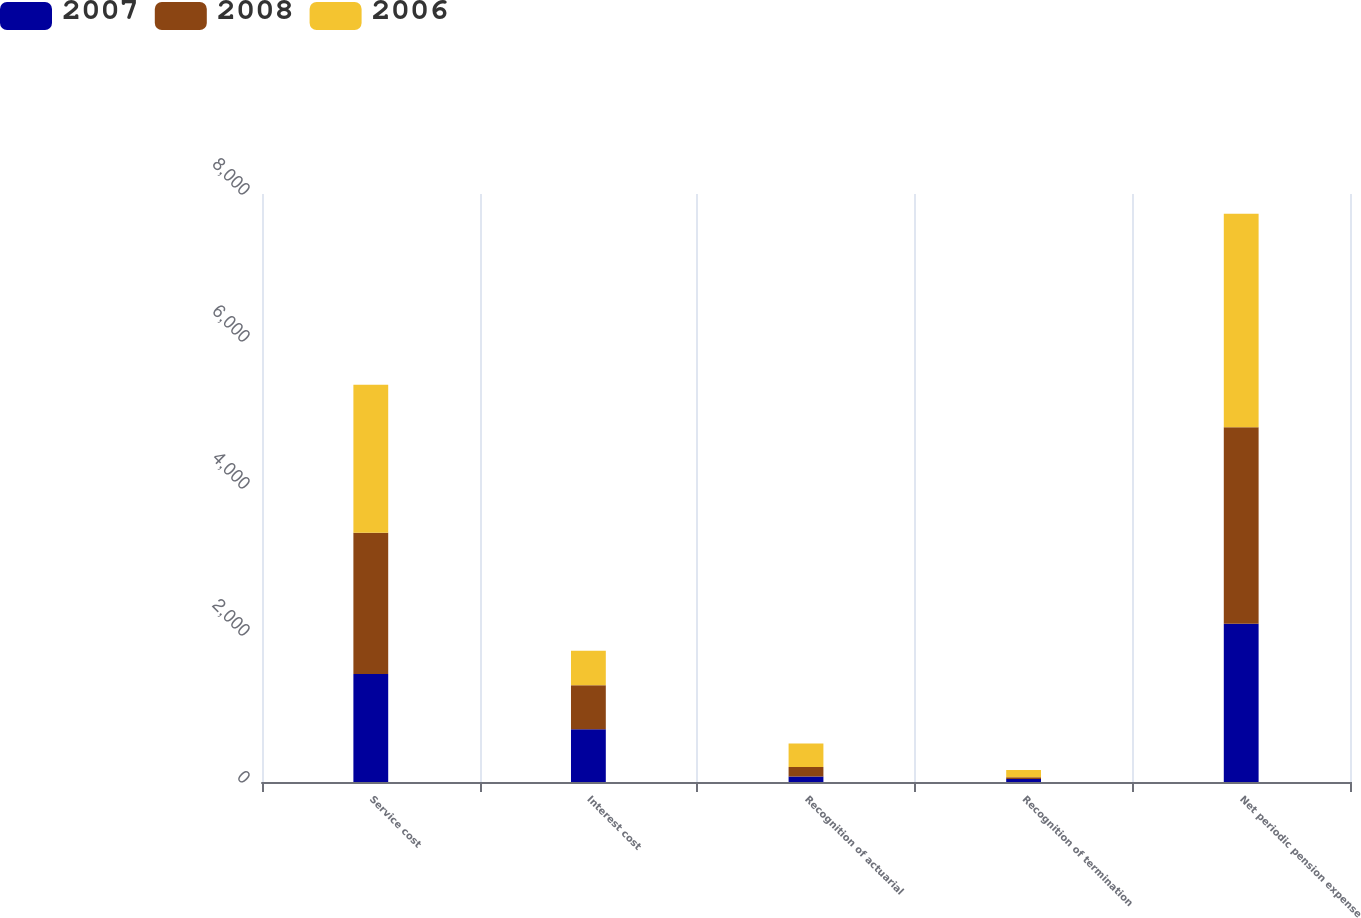Convert chart to OTSL. <chart><loc_0><loc_0><loc_500><loc_500><stacked_bar_chart><ecel><fcel>Service cost<fcel>Interest cost<fcel>Recognition of actuarial<fcel>Recognition of termination<fcel>Net periodic pension expense<nl><fcel>2007<fcel>1470<fcel>717<fcel>74<fcel>40<fcel>2153<nl><fcel>2008<fcel>1922<fcel>599<fcel>129<fcel>24<fcel>2674<nl><fcel>2006<fcel>2013<fcel>471<fcel>321<fcel>98<fcel>2903<nl></chart> 